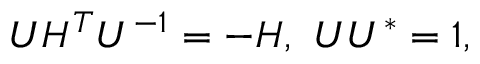<formula> <loc_0><loc_0><loc_500><loc_500>U H ^ { T } U ^ { - 1 } = - H , \ U U ^ { * } = 1 ,</formula> 